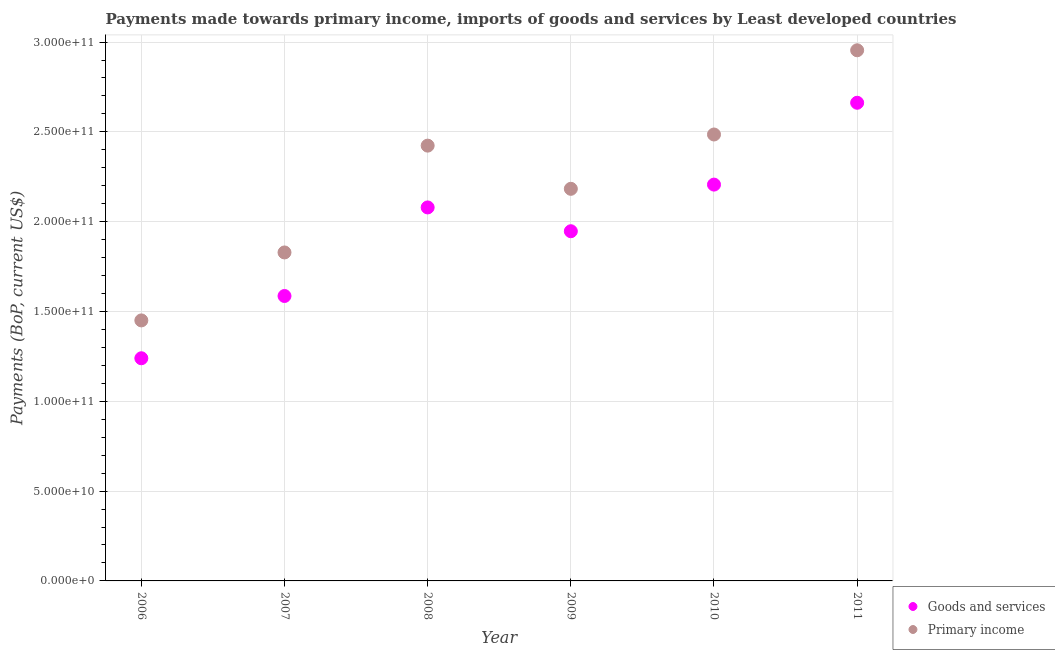How many different coloured dotlines are there?
Offer a terse response. 2. What is the payments made towards primary income in 2006?
Give a very brief answer. 1.45e+11. Across all years, what is the maximum payments made towards primary income?
Ensure brevity in your answer.  2.95e+11. Across all years, what is the minimum payments made towards primary income?
Make the answer very short. 1.45e+11. What is the total payments made towards primary income in the graph?
Offer a terse response. 1.33e+12. What is the difference between the payments made towards primary income in 2007 and that in 2010?
Make the answer very short. -6.57e+1. What is the difference between the payments made towards primary income in 2011 and the payments made towards goods and services in 2008?
Your answer should be compact. 8.75e+1. What is the average payments made towards goods and services per year?
Ensure brevity in your answer.  1.95e+11. In the year 2010, what is the difference between the payments made towards primary income and payments made towards goods and services?
Your response must be concise. 2.79e+1. What is the ratio of the payments made towards goods and services in 2006 to that in 2011?
Make the answer very short. 0.47. Is the payments made towards goods and services in 2008 less than that in 2009?
Offer a very short reply. No. Is the difference between the payments made towards goods and services in 2010 and 2011 greater than the difference between the payments made towards primary income in 2010 and 2011?
Ensure brevity in your answer.  Yes. What is the difference between the highest and the second highest payments made towards primary income?
Your response must be concise. 4.69e+1. What is the difference between the highest and the lowest payments made towards primary income?
Provide a succinct answer. 1.50e+11. Is the sum of the payments made towards primary income in 2007 and 2011 greater than the maximum payments made towards goods and services across all years?
Give a very brief answer. Yes. Is the payments made towards goods and services strictly greater than the payments made towards primary income over the years?
Give a very brief answer. No. How many years are there in the graph?
Keep it short and to the point. 6. What is the difference between two consecutive major ticks on the Y-axis?
Provide a short and direct response. 5.00e+1. Does the graph contain grids?
Your answer should be compact. Yes. Where does the legend appear in the graph?
Your answer should be compact. Bottom right. How many legend labels are there?
Ensure brevity in your answer.  2. How are the legend labels stacked?
Your answer should be very brief. Vertical. What is the title of the graph?
Ensure brevity in your answer.  Payments made towards primary income, imports of goods and services by Least developed countries. What is the label or title of the X-axis?
Your answer should be compact. Year. What is the label or title of the Y-axis?
Provide a succinct answer. Payments (BoP, current US$). What is the Payments (BoP, current US$) of Goods and services in 2006?
Keep it short and to the point. 1.24e+11. What is the Payments (BoP, current US$) in Primary income in 2006?
Give a very brief answer. 1.45e+11. What is the Payments (BoP, current US$) in Goods and services in 2007?
Keep it short and to the point. 1.59e+11. What is the Payments (BoP, current US$) in Primary income in 2007?
Provide a succinct answer. 1.83e+11. What is the Payments (BoP, current US$) in Goods and services in 2008?
Ensure brevity in your answer.  2.08e+11. What is the Payments (BoP, current US$) of Primary income in 2008?
Your answer should be compact. 2.42e+11. What is the Payments (BoP, current US$) of Goods and services in 2009?
Your answer should be very brief. 1.95e+11. What is the Payments (BoP, current US$) of Primary income in 2009?
Your answer should be compact. 2.18e+11. What is the Payments (BoP, current US$) of Goods and services in 2010?
Make the answer very short. 2.21e+11. What is the Payments (BoP, current US$) of Primary income in 2010?
Offer a terse response. 2.49e+11. What is the Payments (BoP, current US$) in Goods and services in 2011?
Your response must be concise. 2.66e+11. What is the Payments (BoP, current US$) of Primary income in 2011?
Keep it short and to the point. 2.95e+11. Across all years, what is the maximum Payments (BoP, current US$) of Goods and services?
Ensure brevity in your answer.  2.66e+11. Across all years, what is the maximum Payments (BoP, current US$) of Primary income?
Keep it short and to the point. 2.95e+11. Across all years, what is the minimum Payments (BoP, current US$) in Goods and services?
Your answer should be very brief. 1.24e+11. Across all years, what is the minimum Payments (BoP, current US$) in Primary income?
Your answer should be very brief. 1.45e+11. What is the total Payments (BoP, current US$) of Goods and services in the graph?
Your response must be concise. 1.17e+12. What is the total Payments (BoP, current US$) of Primary income in the graph?
Offer a terse response. 1.33e+12. What is the difference between the Payments (BoP, current US$) in Goods and services in 2006 and that in 2007?
Give a very brief answer. -3.47e+1. What is the difference between the Payments (BoP, current US$) of Primary income in 2006 and that in 2007?
Provide a succinct answer. -3.78e+1. What is the difference between the Payments (BoP, current US$) in Goods and services in 2006 and that in 2008?
Your response must be concise. -8.40e+1. What is the difference between the Payments (BoP, current US$) in Primary income in 2006 and that in 2008?
Provide a short and direct response. -9.73e+1. What is the difference between the Payments (BoP, current US$) of Goods and services in 2006 and that in 2009?
Ensure brevity in your answer.  -7.07e+1. What is the difference between the Payments (BoP, current US$) of Primary income in 2006 and that in 2009?
Ensure brevity in your answer.  -7.33e+1. What is the difference between the Payments (BoP, current US$) of Goods and services in 2006 and that in 2010?
Provide a short and direct response. -9.67e+1. What is the difference between the Payments (BoP, current US$) of Primary income in 2006 and that in 2010?
Offer a terse response. -1.04e+11. What is the difference between the Payments (BoP, current US$) in Goods and services in 2006 and that in 2011?
Keep it short and to the point. -1.42e+11. What is the difference between the Payments (BoP, current US$) in Primary income in 2006 and that in 2011?
Provide a succinct answer. -1.50e+11. What is the difference between the Payments (BoP, current US$) of Goods and services in 2007 and that in 2008?
Keep it short and to the point. -4.93e+1. What is the difference between the Payments (BoP, current US$) of Primary income in 2007 and that in 2008?
Offer a very short reply. -5.95e+1. What is the difference between the Payments (BoP, current US$) of Goods and services in 2007 and that in 2009?
Your answer should be compact. -3.61e+1. What is the difference between the Payments (BoP, current US$) in Primary income in 2007 and that in 2009?
Your answer should be very brief. -3.54e+1. What is the difference between the Payments (BoP, current US$) of Goods and services in 2007 and that in 2010?
Ensure brevity in your answer.  -6.20e+1. What is the difference between the Payments (BoP, current US$) of Primary income in 2007 and that in 2010?
Your answer should be very brief. -6.57e+1. What is the difference between the Payments (BoP, current US$) in Goods and services in 2007 and that in 2011?
Your answer should be very brief. -1.08e+11. What is the difference between the Payments (BoP, current US$) in Primary income in 2007 and that in 2011?
Keep it short and to the point. -1.13e+11. What is the difference between the Payments (BoP, current US$) of Goods and services in 2008 and that in 2009?
Offer a very short reply. 1.32e+1. What is the difference between the Payments (BoP, current US$) in Primary income in 2008 and that in 2009?
Make the answer very short. 2.40e+1. What is the difference between the Payments (BoP, current US$) of Goods and services in 2008 and that in 2010?
Your answer should be very brief. -1.27e+1. What is the difference between the Payments (BoP, current US$) of Primary income in 2008 and that in 2010?
Offer a very short reply. -6.20e+09. What is the difference between the Payments (BoP, current US$) of Goods and services in 2008 and that in 2011?
Provide a succinct answer. -5.83e+1. What is the difference between the Payments (BoP, current US$) of Primary income in 2008 and that in 2011?
Your answer should be very brief. -5.31e+1. What is the difference between the Payments (BoP, current US$) in Goods and services in 2009 and that in 2010?
Provide a short and direct response. -2.60e+1. What is the difference between the Payments (BoP, current US$) of Primary income in 2009 and that in 2010?
Offer a terse response. -3.02e+1. What is the difference between the Payments (BoP, current US$) in Goods and services in 2009 and that in 2011?
Offer a terse response. -7.15e+1. What is the difference between the Payments (BoP, current US$) in Primary income in 2009 and that in 2011?
Keep it short and to the point. -7.71e+1. What is the difference between the Payments (BoP, current US$) in Goods and services in 2010 and that in 2011?
Provide a succinct answer. -4.56e+1. What is the difference between the Payments (BoP, current US$) in Primary income in 2010 and that in 2011?
Your answer should be very brief. -4.69e+1. What is the difference between the Payments (BoP, current US$) in Goods and services in 2006 and the Payments (BoP, current US$) in Primary income in 2007?
Keep it short and to the point. -5.89e+1. What is the difference between the Payments (BoP, current US$) in Goods and services in 2006 and the Payments (BoP, current US$) in Primary income in 2008?
Offer a terse response. -1.18e+11. What is the difference between the Payments (BoP, current US$) in Goods and services in 2006 and the Payments (BoP, current US$) in Primary income in 2009?
Ensure brevity in your answer.  -9.43e+1. What is the difference between the Payments (BoP, current US$) in Goods and services in 2006 and the Payments (BoP, current US$) in Primary income in 2010?
Provide a succinct answer. -1.25e+11. What is the difference between the Payments (BoP, current US$) of Goods and services in 2006 and the Payments (BoP, current US$) of Primary income in 2011?
Offer a very short reply. -1.71e+11. What is the difference between the Payments (BoP, current US$) of Goods and services in 2007 and the Payments (BoP, current US$) of Primary income in 2008?
Make the answer very short. -8.37e+1. What is the difference between the Payments (BoP, current US$) of Goods and services in 2007 and the Payments (BoP, current US$) of Primary income in 2009?
Provide a succinct answer. -5.97e+1. What is the difference between the Payments (BoP, current US$) of Goods and services in 2007 and the Payments (BoP, current US$) of Primary income in 2010?
Provide a short and direct response. -8.99e+1. What is the difference between the Payments (BoP, current US$) in Goods and services in 2007 and the Payments (BoP, current US$) in Primary income in 2011?
Ensure brevity in your answer.  -1.37e+11. What is the difference between the Payments (BoP, current US$) of Goods and services in 2008 and the Payments (BoP, current US$) of Primary income in 2009?
Provide a succinct answer. -1.04e+1. What is the difference between the Payments (BoP, current US$) of Goods and services in 2008 and the Payments (BoP, current US$) of Primary income in 2010?
Your response must be concise. -4.06e+1. What is the difference between the Payments (BoP, current US$) in Goods and services in 2008 and the Payments (BoP, current US$) in Primary income in 2011?
Your answer should be compact. -8.75e+1. What is the difference between the Payments (BoP, current US$) of Goods and services in 2009 and the Payments (BoP, current US$) of Primary income in 2010?
Your response must be concise. -5.39e+1. What is the difference between the Payments (BoP, current US$) in Goods and services in 2009 and the Payments (BoP, current US$) in Primary income in 2011?
Offer a terse response. -1.01e+11. What is the difference between the Payments (BoP, current US$) of Goods and services in 2010 and the Payments (BoP, current US$) of Primary income in 2011?
Give a very brief answer. -7.48e+1. What is the average Payments (BoP, current US$) in Goods and services per year?
Your response must be concise. 1.95e+11. What is the average Payments (BoP, current US$) of Primary income per year?
Ensure brevity in your answer.  2.22e+11. In the year 2006, what is the difference between the Payments (BoP, current US$) in Goods and services and Payments (BoP, current US$) in Primary income?
Provide a short and direct response. -2.11e+1. In the year 2007, what is the difference between the Payments (BoP, current US$) of Goods and services and Payments (BoP, current US$) of Primary income?
Your answer should be very brief. -2.42e+1. In the year 2008, what is the difference between the Payments (BoP, current US$) in Goods and services and Payments (BoP, current US$) in Primary income?
Offer a very short reply. -3.44e+1. In the year 2009, what is the difference between the Payments (BoP, current US$) in Goods and services and Payments (BoP, current US$) in Primary income?
Provide a succinct answer. -2.36e+1. In the year 2010, what is the difference between the Payments (BoP, current US$) in Goods and services and Payments (BoP, current US$) in Primary income?
Ensure brevity in your answer.  -2.79e+1. In the year 2011, what is the difference between the Payments (BoP, current US$) in Goods and services and Payments (BoP, current US$) in Primary income?
Make the answer very short. -2.92e+1. What is the ratio of the Payments (BoP, current US$) in Goods and services in 2006 to that in 2007?
Provide a succinct answer. 0.78. What is the ratio of the Payments (BoP, current US$) in Primary income in 2006 to that in 2007?
Provide a short and direct response. 0.79. What is the ratio of the Payments (BoP, current US$) in Goods and services in 2006 to that in 2008?
Provide a succinct answer. 0.6. What is the ratio of the Payments (BoP, current US$) of Primary income in 2006 to that in 2008?
Your answer should be very brief. 0.6. What is the ratio of the Payments (BoP, current US$) of Goods and services in 2006 to that in 2009?
Offer a very short reply. 0.64. What is the ratio of the Payments (BoP, current US$) of Primary income in 2006 to that in 2009?
Provide a succinct answer. 0.66. What is the ratio of the Payments (BoP, current US$) in Goods and services in 2006 to that in 2010?
Your response must be concise. 0.56. What is the ratio of the Payments (BoP, current US$) of Primary income in 2006 to that in 2010?
Keep it short and to the point. 0.58. What is the ratio of the Payments (BoP, current US$) in Goods and services in 2006 to that in 2011?
Give a very brief answer. 0.47. What is the ratio of the Payments (BoP, current US$) in Primary income in 2006 to that in 2011?
Your answer should be compact. 0.49. What is the ratio of the Payments (BoP, current US$) in Goods and services in 2007 to that in 2008?
Your answer should be very brief. 0.76. What is the ratio of the Payments (BoP, current US$) in Primary income in 2007 to that in 2008?
Ensure brevity in your answer.  0.75. What is the ratio of the Payments (BoP, current US$) in Goods and services in 2007 to that in 2009?
Your answer should be compact. 0.81. What is the ratio of the Payments (BoP, current US$) in Primary income in 2007 to that in 2009?
Your answer should be very brief. 0.84. What is the ratio of the Payments (BoP, current US$) in Goods and services in 2007 to that in 2010?
Make the answer very short. 0.72. What is the ratio of the Payments (BoP, current US$) of Primary income in 2007 to that in 2010?
Offer a terse response. 0.74. What is the ratio of the Payments (BoP, current US$) in Goods and services in 2007 to that in 2011?
Your response must be concise. 0.6. What is the ratio of the Payments (BoP, current US$) of Primary income in 2007 to that in 2011?
Give a very brief answer. 0.62. What is the ratio of the Payments (BoP, current US$) in Goods and services in 2008 to that in 2009?
Offer a very short reply. 1.07. What is the ratio of the Payments (BoP, current US$) in Primary income in 2008 to that in 2009?
Give a very brief answer. 1.11. What is the ratio of the Payments (BoP, current US$) of Goods and services in 2008 to that in 2010?
Offer a very short reply. 0.94. What is the ratio of the Payments (BoP, current US$) in Goods and services in 2008 to that in 2011?
Give a very brief answer. 0.78. What is the ratio of the Payments (BoP, current US$) in Primary income in 2008 to that in 2011?
Your response must be concise. 0.82. What is the ratio of the Payments (BoP, current US$) in Goods and services in 2009 to that in 2010?
Provide a succinct answer. 0.88. What is the ratio of the Payments (BoP, current US$) of Primary income in 2009 to that in 2010?
Your answer should be compact. 0.88. What is the ratio of the Payments (BoP, current US$) of Goods and services in 2009 to that in 2011?
Ensure brevity in your answer.  0.73. What is the ratio of the Payments (BoP, current US$) of Primary income in 2009 to that in 2011?
Keep it short and to the point. 0.74. What is the ratio of the Payments (BoP, current US$) in Goods and services in 2010 to that in 2011?
Your answer should be very brief. 0.83. What is the ratio of the Payments (BoP, current US$) in Primary income in 2010 to that in 2011?
Offer a terse response. 0.84. What is the difference between the highest and the second highest Payments (BoP, current US$) of Goods and services?
Give a very brief answer. 4.56e+1. What is the difference between the highest and the second highest Payments (BoP, current US$) in Primary income?
Offer a terse response. 4.69e+1. What is the difference between the highest and the lowest Payments (BoP, current US$) in Goods and services?
Your response must be concise. 1.42e+11. What is the difference between the highest and the lowest Payments (BoP, current US$) in Primary income?
Ensure brevity in your answer.  1.50e+11. 